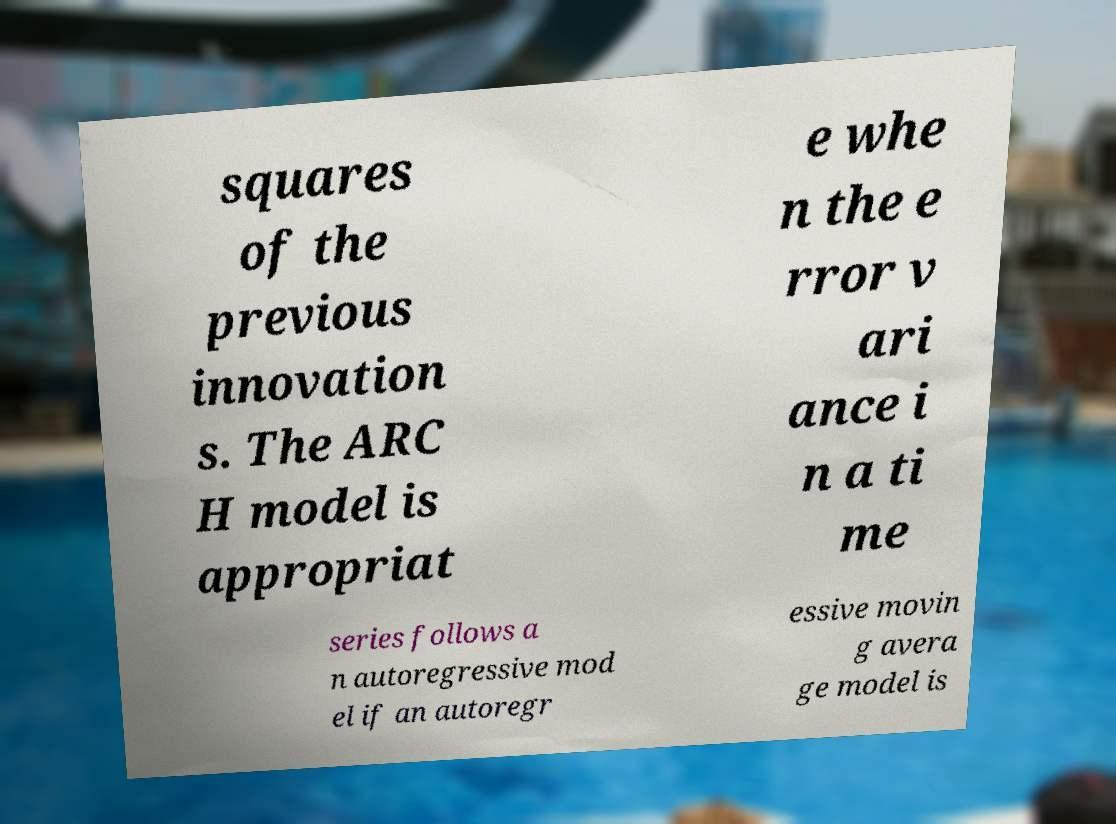I need the written content from this picture converted into text. Can you do that? squares of the previous innovation s. The ARC H model is appropriat e whe n the e rror v ari ance i n a ti me series follows a n autoregressive mod el if an autoregr essive movin g avera ge model is 